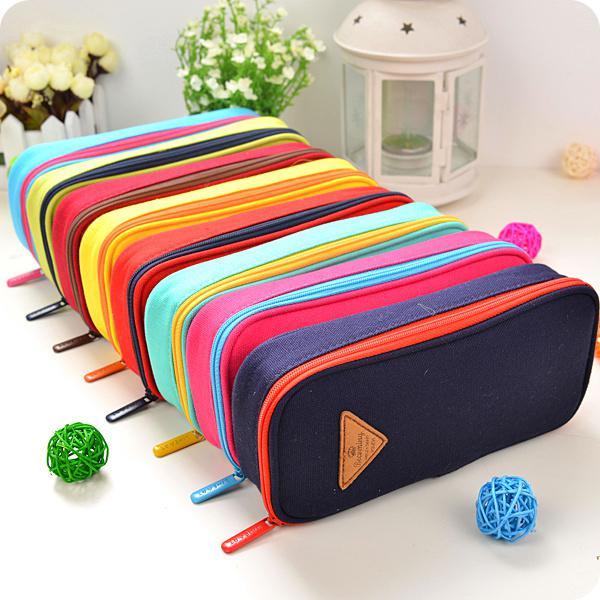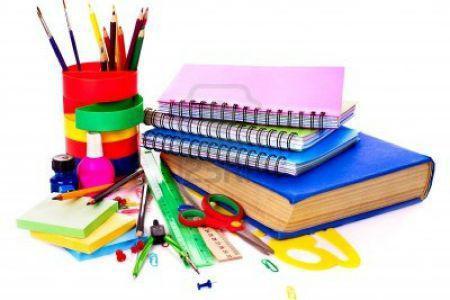The first image is the image on the left, the second image is the image on the right. Assess this claim about the two images: "There is one image that includes only pencil cases zipped closed, and none are open.". Correct or not? Answer yes or no. Yes. The first image is the image on the left, the second image is the image on the right. For the images displayed, is the sentence "One image shows at least four cases in different solid colors with rounded edges, and only one is open and filled with supplies." factually correct? Answer yes or no. No. 